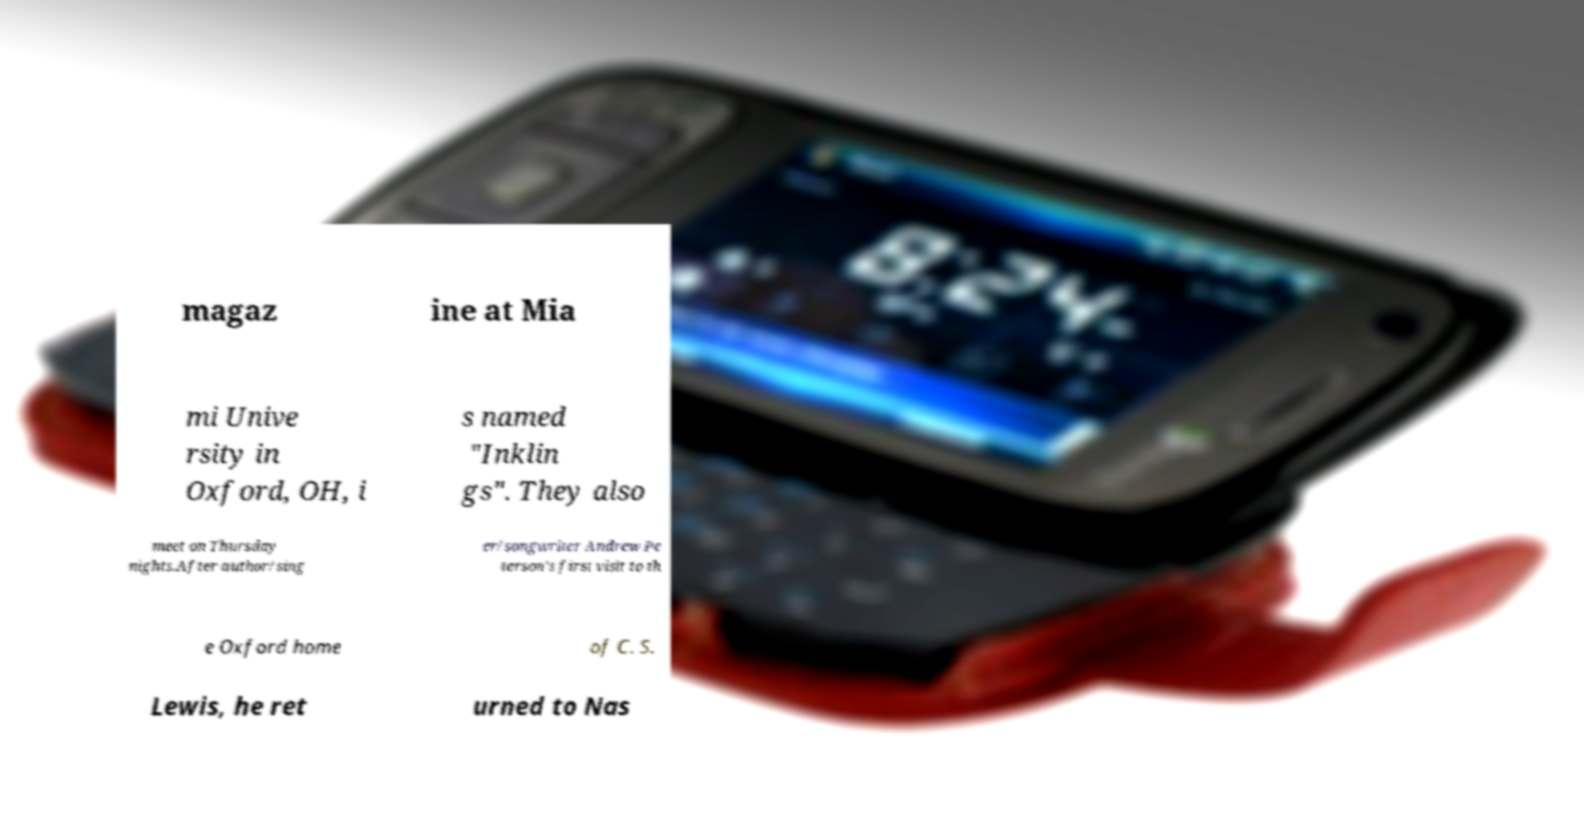Can you accurately transcribe the text from the provided image for me? magaz ine at Mia mi Unive rsity in Oxford, OH, i s named "Inklin gs". They also meet on Thursday nights.After author/sing er/songwriter Andrew Pe terson's first visit to th e Oxford home of C. S. Lewis, he ret urned to Nas 